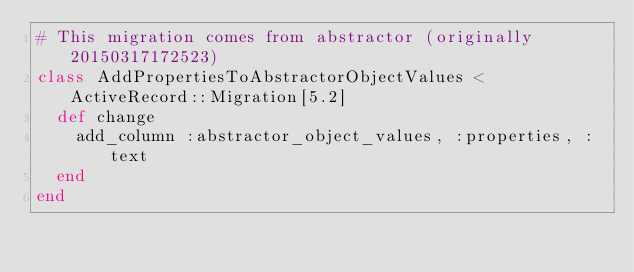<code> <loc_0><loc_0><loc_500><loc_500><_Ruby_># This migration comes from abstractor (originally 20150317172523)
class AddPropertiesToAbstractorObjectValues < ActiveRecord::Migration[5.2]
  def change
    add_column :abstractor_object_values, :properties, :text
  end
end
</code> 